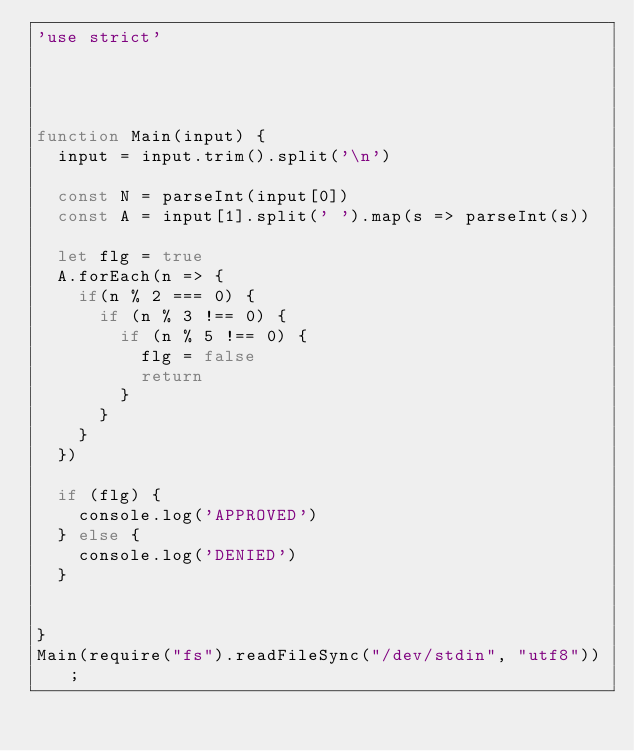Convert code to text. <code><loc_0><loc_0><loc_500><loc_500><_JavaScript_>'use strict'




function Main(input) {
  input = input.trim().split('\n')

  const N = parseInt(input[0])
  const A = input[1].split(' ').map(s => parseInt(s))

  let flg = true
  A.forEach(n => {
    if(n % 2 === 0) {
      if (n % 3 !== 0) {
        if (n % 5 !== 0) {
          flg = false
          return
        }
      }
    }
  })

  if (flg) {
    console.log('APPROVED')
  } else {
    console.log('DENIED')
  }


}
Main(require("fs").readFileSync("/dev/stdin", "utf8"));</code> 